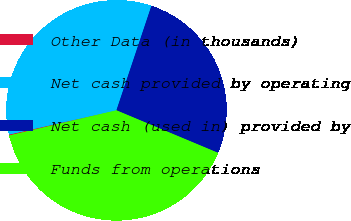Convert chart to OTSL. <chart><loc_0><loc_0><loc_500><loc_500><pie_chart><fcel>Other Data (in thousands)<fcel>Net cash provided by operating<fcel>Net cash (used in) provided by<fcel>Funds from operations<nl><fcel>0.14%<fcel>33.67%<fcel>26.17%<fcel>40.03%<nl></chart> 